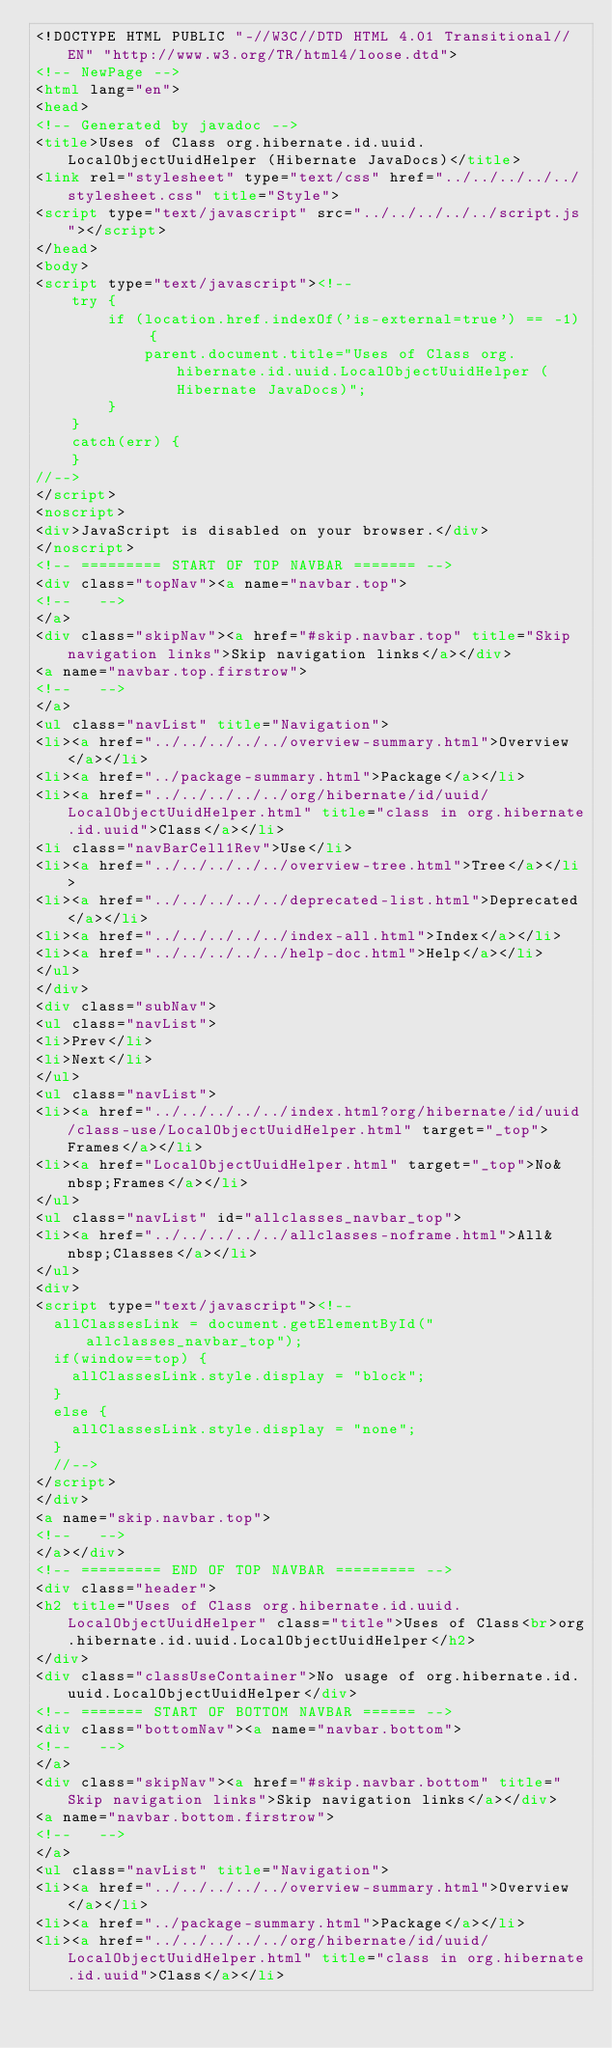<code> <loc_0><loc_0><loc_500><loc_500><_HTML_><!DOCTYPE HTML PUBLIC "-//W3C//DTD HTML 4.01 Transitional//EN" "http://www.w3.org/TR/html4/loose.dtd">
<!-- NewPage -->
<html lang="en">
<head>
<!-- Generated by javadoc -->
<title>Uses of Class org.hibernate.id.uuid.LocalObjectUuidHelper (Hibernate JavaDocs)</title>
<link rel="stylesheet" type="text/css" href="../../../../../stylesheet.css" title="Style">
<script type="text/javascript" src="../../../../../script.js"></script>
</head>
<body>
<script type="text/javascript"><!--
    try {
        if (location.href.indexOf('is-external=true') == -1) {
            parent.document.title="Uses of Class org.hibernate.id.uuid.LocalObjectUuidHelper (Hibernate JavaDocs)";
        }
    }
    catch(err) {
    }
//-->
</script>
<noscript>
<div>JavaScript is disabled on your browser.</div>
</noscript>
<!-- ========= START OF TOP NAVBAR ======= -->
<div class="topNav"><a name="navbar.top">
<!--   -->
</a>
<div class="skipNav"><a href="#skip.navbar.top" title="Skip navigation links">Skip navigation links</a></div>
<a name="navbar.top.firstrow">
<!--   -->
</a>
<ul class="navList" title="Navigation">
<li><a href="../../../../../overview-summary.html">Overview</a></li>
<li><a href="../package-summary.html">Package</a></li>
<li><a href="../../../../../org/hibernate/id/uuid/LocalObjectUuidHelper.html" title="class in org.hibernate.id.uuid">Class</a></li>
<li class="navBarCell1Rev">Use</li>
<li><a href="../../../../../overview-tree.html">Tree</a></li>
<li><a href="../../../../../deprecated-list.html">Deprecated</a></li>
<li><a href="../../../../../index-all.html">Index</a></li>
<li><a href="../../../../../help-doc.html">Help</a></li>
</ul>
</div>
<div class="subNav">
<ul class="navList">
<li>Prev</li>
<li>Next</li>
</ul>
<ul class="navList">
<li><a href="../../../../../index.html?org/hibernate/id/uuid/class-use/LocalObjectUuidHelper.html" target="_top">Frames</a></li>
<li><a href="LocalObjectUuidHelper.html" target="_top">No&nbsp;Frames</a></li>
</ul>
<ul class="navList" id="allclasses_navbar_top">
<li><a href="../../../../../allclasses-noframe.html">All&nbsp;Classes</a></li>
</ul>
<div>
<script type="text/javascript"><!--
  allClassesLink = document.getElementById("allclasses_navbar_top");
  if(window==top) {
    allClassesLink.style.display = "block";
  }
  else {
    allClassesLink.style.display = "none";
  }
  //-->
</script>
</div>
<a name="skip.navbar.top">
<!--   -->
</a></div>
<!-- ========= END OF TOP NAVBAR ========= -->
<div class="header">
<h2 title="Uses of Class org.hibernate.id.uuid.LocalObjectUuidHelper" class="title">Uses of Class<br>org.hibernate.id.uuid.LocalObjectUuidHelper</h2>
</div>
<div class="classUseContainer">No usage of org.hibernate.id.uuid.LocalObjectUuidHelper</div>
<!-- ======= START OF BOTTOM NAVBAR ====== -->
<div class="bottomNav"><a name="navbar.bottom">
<!--   -->
</a>
<div class="skipNav"><a href="#skip.navbar.bottom" title="Skip navigation links">Skip navigation links</a></div>
<a name="navbar.bottom.firstrow">
<!--   -->
</a>
<ul class="navList" title="Navigation">
<li><a href="../../../../../overview-summary.html">Overview</a></li>
<li><a href="../package-summary.html">Package</a></li>
<li><a href="../../../../../org/hibernate/id/uuid/LocalObjectUuidHelper.html" title="class in org.hibernate.id.uuid">Class</a></li></code> 